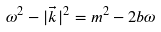<formula> <loc_0><loc_0><loc_500><loc_500>\omega ^ { 2 } - | \vec { k } | ^ { 2 } = m ^ { 2 } - 2 b \omega</formula> 